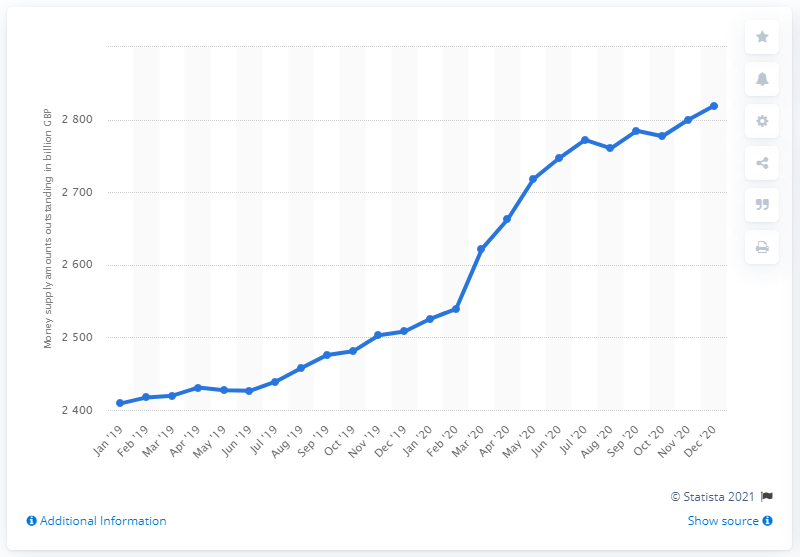Draw attention to some important aspects in this diagram. In the most recent month displayed, the total money supply was 2819.01. 